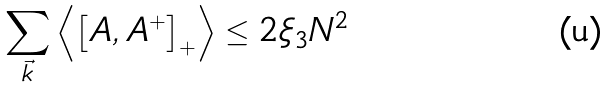Convert formula to latex. <formula><loc_0><loc_0><loc_500><loc_500>\sum _ { \vec { k } } \left \langle \left [ A , A ^ { + } \right ] _ { + } \right \rangle \leq 2 \xi _ { 3 } N ^ { 2 }</formula> 